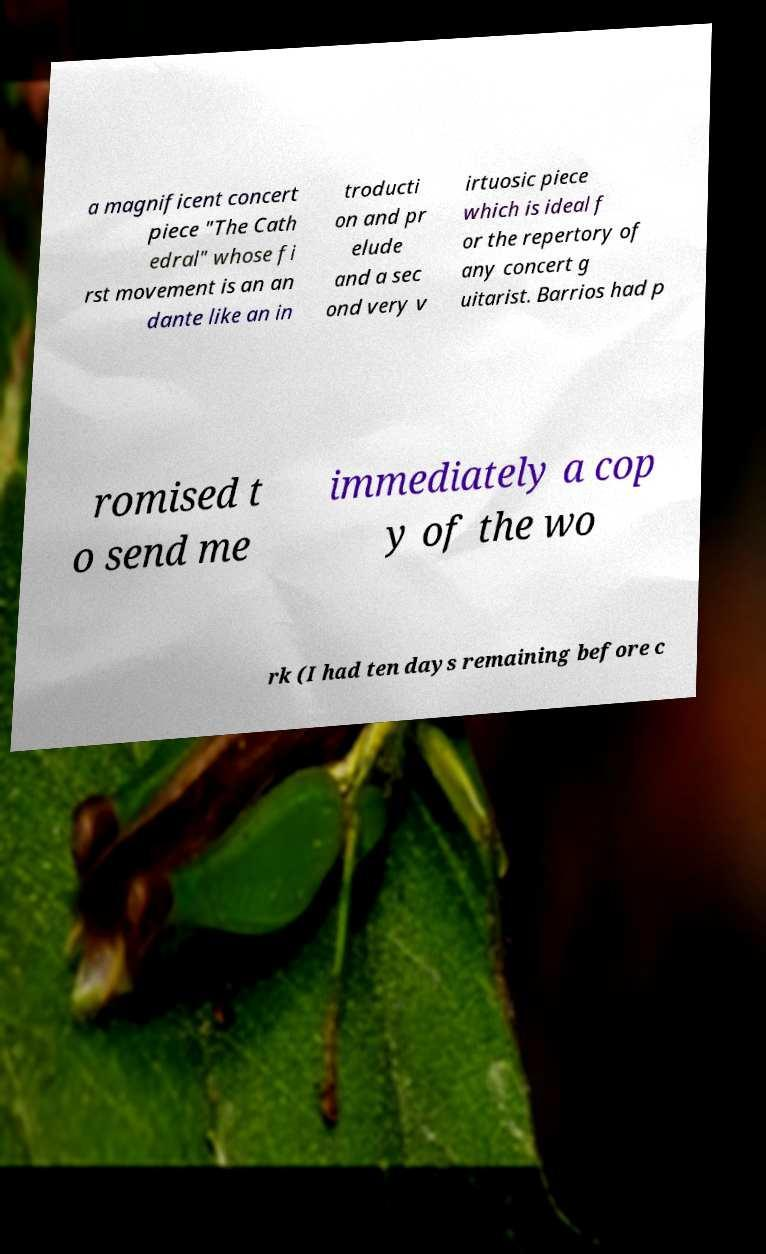Please identify and transcribe the text found in this image. a magnificent concert piece "The Cath edral" whose fi rst movement is an an dante like an in troducti on and pr elude and a sec ond very v irtuosic piece which is ideal f or the repertory of any concert g uitarist. Barrios had p romised t o send me immediately a cop y of the wo rk (I had ten days remaining before c 